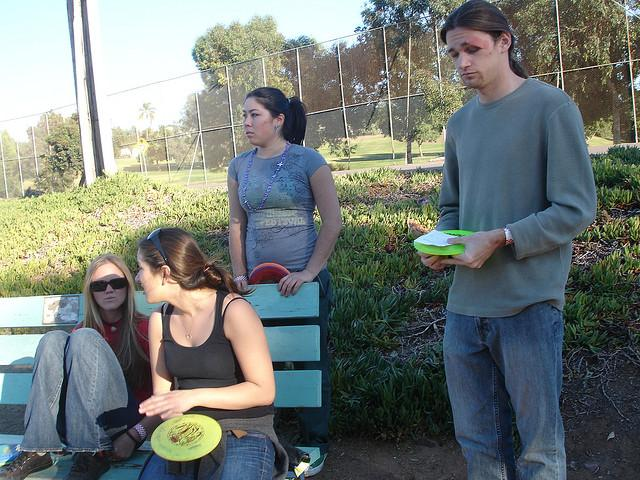What are they doing? Please explain your reasoning. eating lunch. The people are resting from their game. 